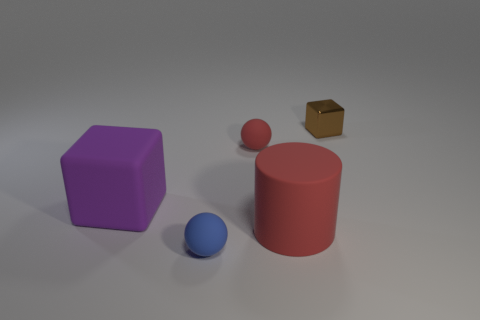Add 3 tiny red matte objects. How many objects exist? 8 Subtract all cubes. How many objects are left? 3 Add 2 blue objects. How many blue objects are left? 3 Add 1 red matte cubes. How many red matte cubes exist? 1 Subtract 0 green cylinders. How many objects are left? 5 Subtract all red objects. Subtract all small brown cubes. How many objects are left? 2 